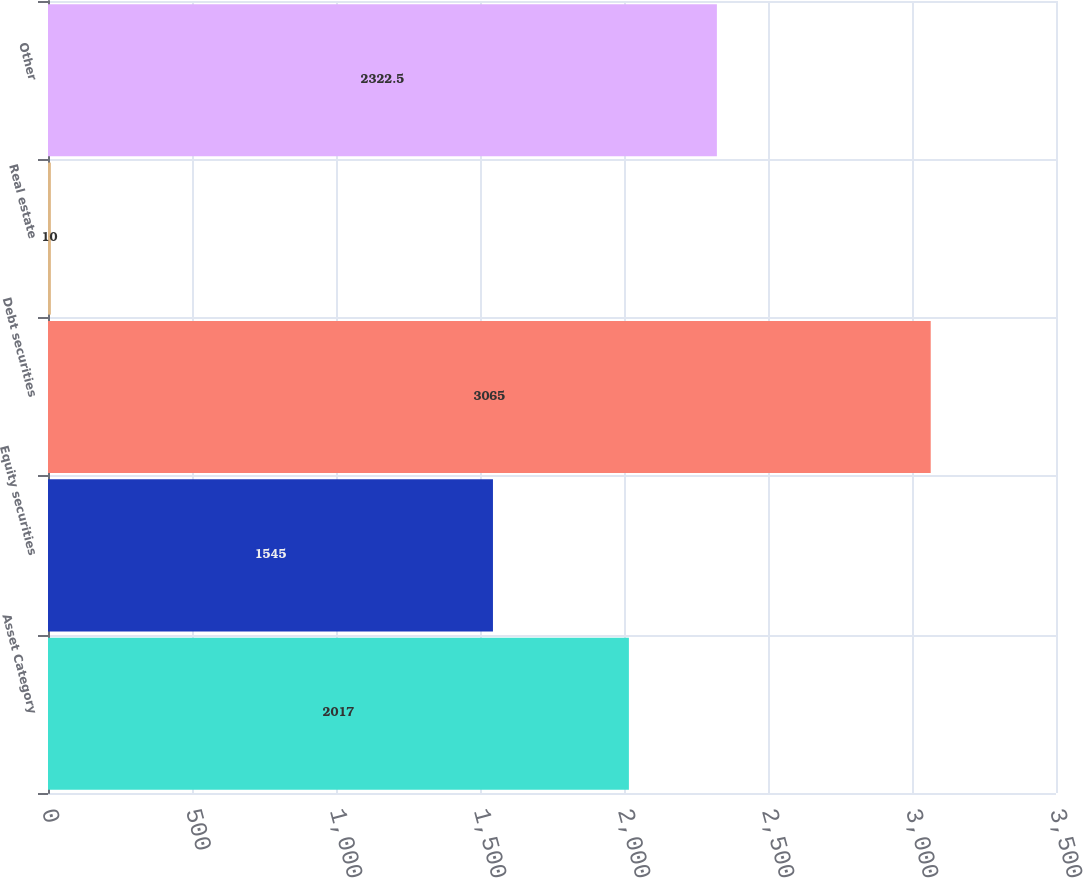Convert chart to OTSL. <chart><loc_0><loc_0><loc_500><loc_500><bar_chart><fcel>Asset Category<fcel>Equity securities<fcel>Debt securities<fcel>Real estate<fcel>Other<nl><fcel>2017<fcel>1545<fcel>3065<fcel>10<fcel>2322.5<nl></chart> 